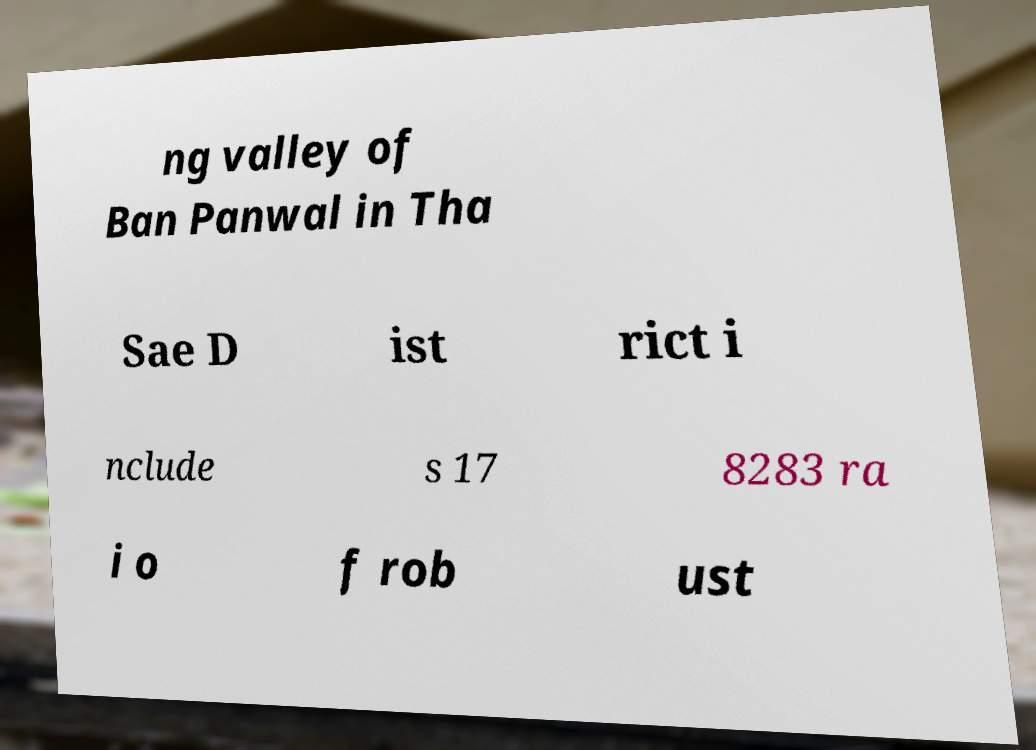Can you read and provide the text displayed in the image?This photo seems to have some interesting text. Can you extract and type it out for me? ng valley of Ban Panwal in Tha Sae D ist rict i nclude s 17 8283 ra i o f rob ust 